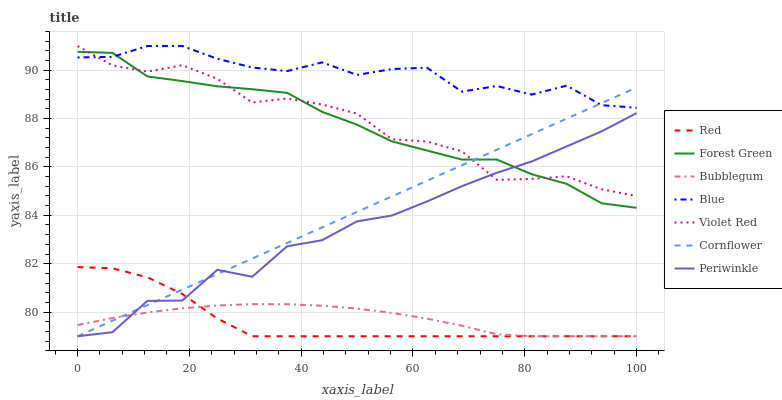Does Red have the minimum area under the curve?
Answer yes or no. Yes. Does Blue have the maximum area under the curve?
Answer yes or no. Yes. Does Cornflower have the minimum area under the curve?
Answer yes or no. No. Does Cornflower have the maximum area under the curve?
Answer yes or no. No. Is Cornflower the smoothest?
Answer yes or no. Yes. Is Periwinkle the roughest?
Answer yes or no. Yes. Is Violet Red the smoothest?
Answer yes or no. No. Is Violet Red the roughest?
Answer yes or no. No. Does Cornflower have the lowest value?
Answer yes or no. Yes. Does Violet Red have the lowest value?
Answer yes or no. No. Does Violet Red have the highest value?
Answer yes or no. Yes. Does Cornflower have the highest value?
Answer yes or no. No. Is Red less than Violet Red?
Answer yes or no. Yes. Is Violet Red greater than Red?
Answer yes or no. Yes. Does Violet Red intersect Blue?
Answer yes or no. Yes. Is Violet Red less than Blue?
Answer yes or no. No. Is Violet Red greater than Blue?
Answer yes or no. No. Does Red intersect Violet Red?
Answer yes or no. No. 